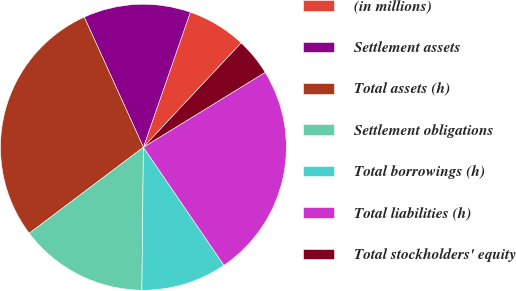Convert chart to OTSL. <chart><loc_0><loc_0><loc_500><loc_500><pie_chart><fcel>(in millions)<fcel>Settlement assets<fcel>Total assets (h)<fcel>Settlement obligations<fcel>Total borrowings (h)<fcel>Total liabilities (h)<fcel>Total stockholders' equity<nl><fcel>6.66%<fcel>12.12%<fcel>28.49%<fcel>14.55%<fcel>9.7%<fcel>24.25%<fcel>4.24%<nl></chart> 